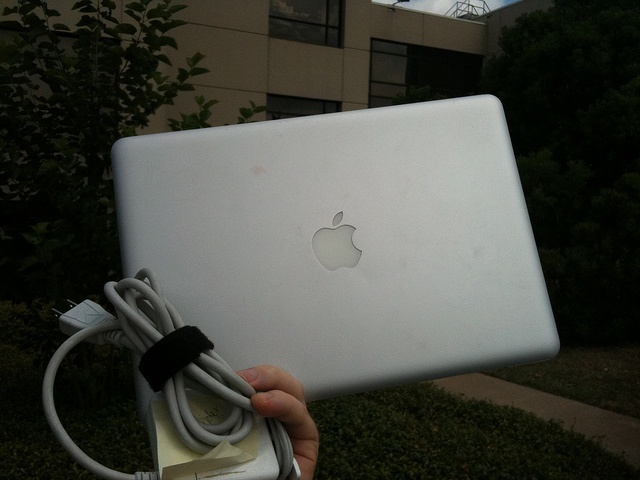Describe the objects in this image and their specific colors. I can see laptop in black, darkgray, and gray tones and people in black, maroon, and gray tones in this image. 